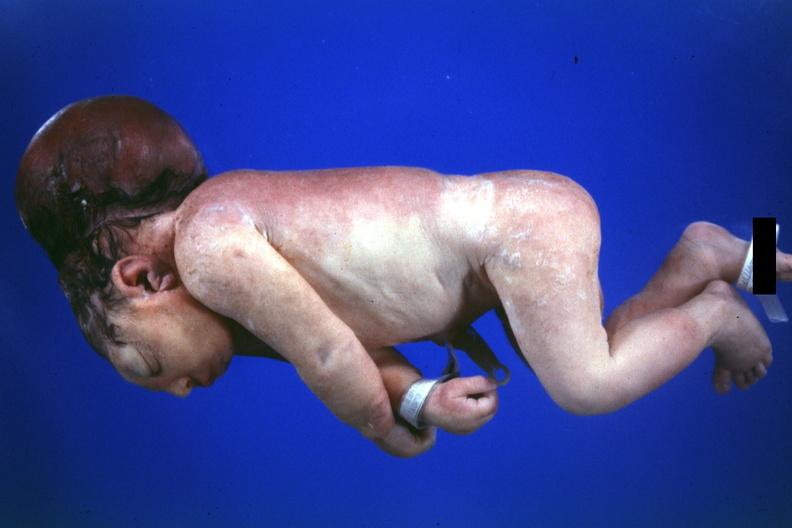what is present?
Answer the question using a single word or phrase. Brain 